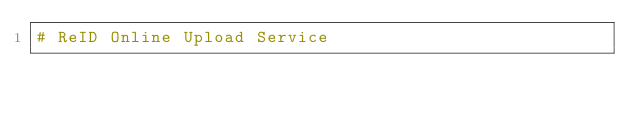<code> <loc_0><loc_0><loc_500><loc_500><_Python_># ReID Online Upload Service</code> 